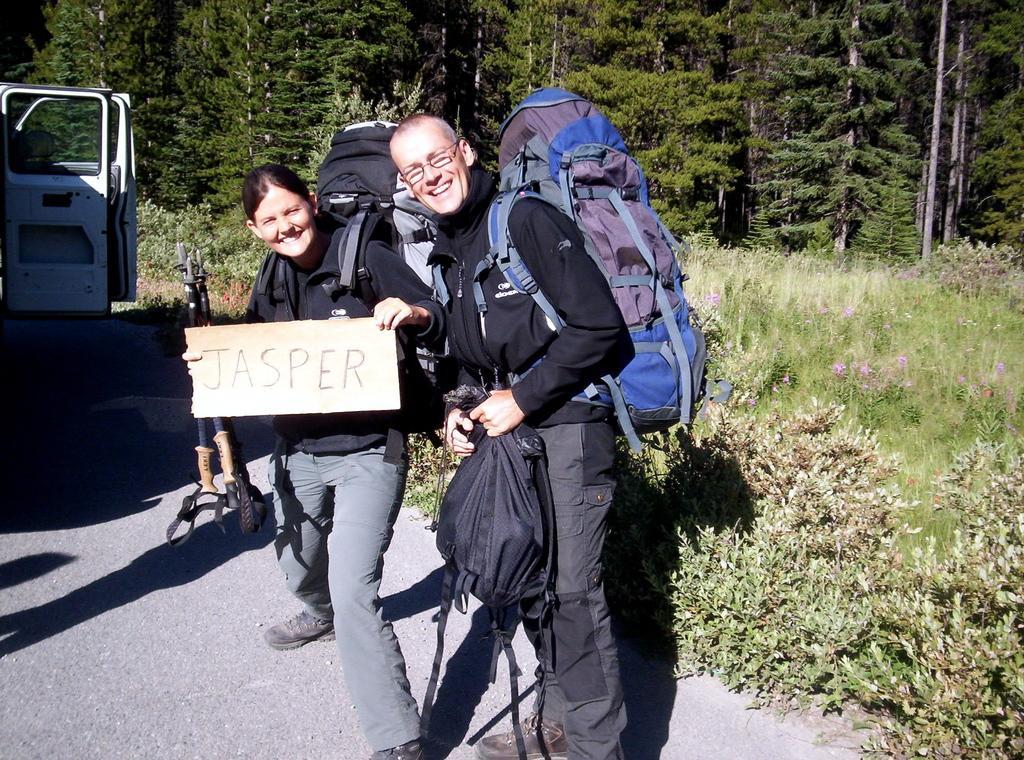Please provide a concise description of this image. These two persons are standing and smiling,wear bags and holding objects. We can see vehicles on the road. On the background we can see trees,plants. 